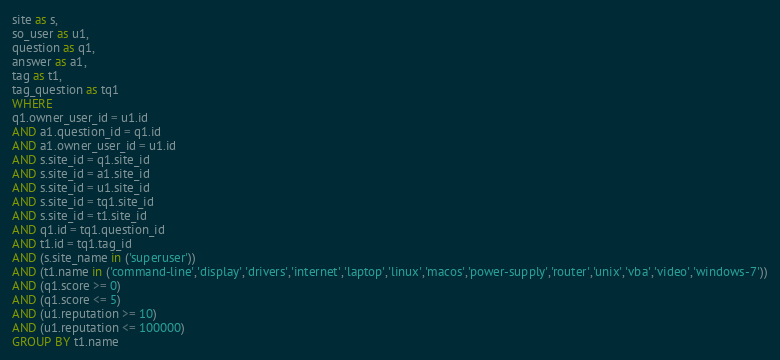Convert code to text. <code><loc_0><loc_0><loc_500><loc_500><_SQL_>site as s,
so_user as u1,
question as q1,
answer as a1,
tag as t1,
tag_question as tq1
WHERE
q1.owner_user_id = u1.id
AND a1.question_id = q1.id
AND a1.owner_user_id = u1.id
AND s.site_id = q1.site_id
AND s.site_id = a1.site_id
AND s.site_id = u1.site_id
AND s.site_id = tq1.site_id
AND s.site_id = t1.site_id
AND q1.id = tq1.question_id
AND t1.id = tq1.tag_id
AND (s.site_name in ('superuser'))
AND (t1.name in ('command-line','display','drivers','internet','laptop','linux','macos','power-supply','router','unix','vba','video','windows-7'))
AND (q1.score >= 0)
AND (q1.score <= 5)
AND (u1.reputation >= 10)
AND (u1.reputation <= 100000)
GROUP BY t1.name</code> 